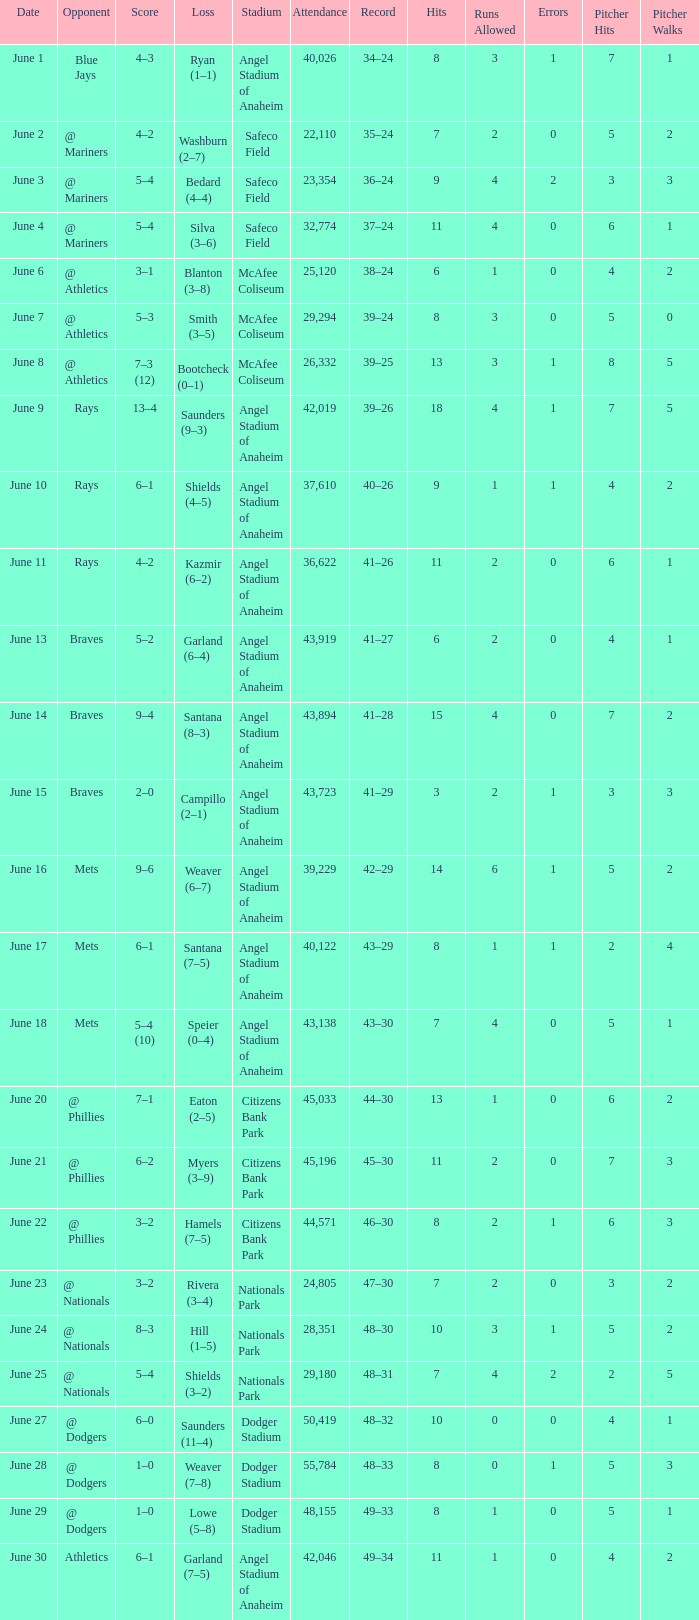What was the score of the game against the Braves with a record of 41–27? 5–2. 